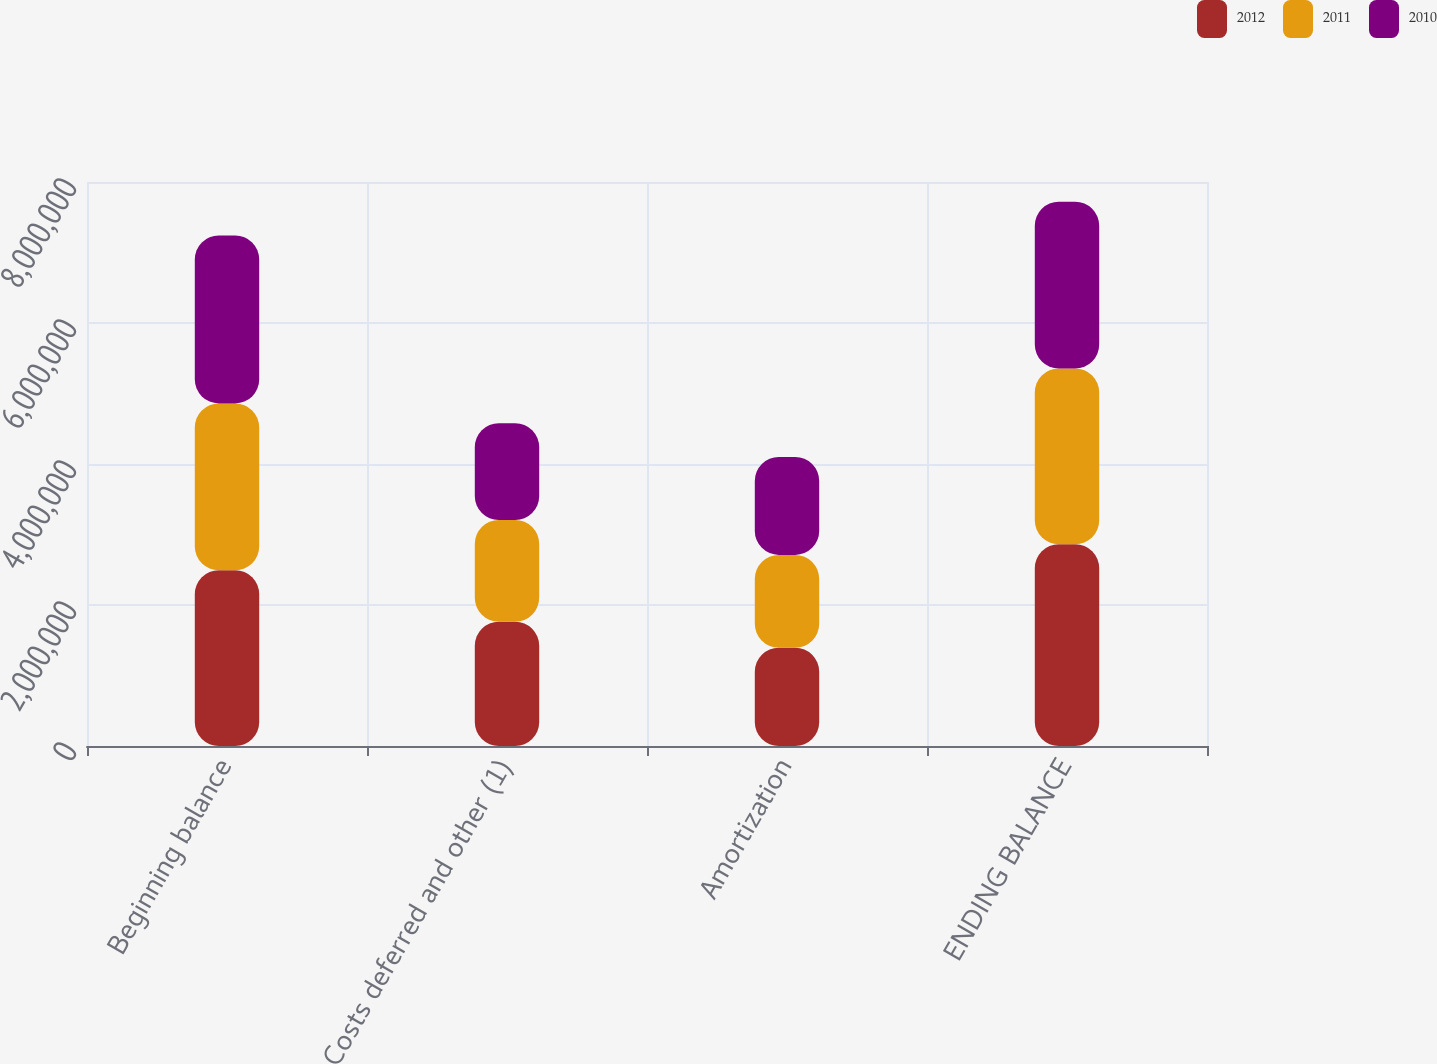Convert chart to OTSL. <chart><loc_0><loc_0><loc_500><loc_500><stacked_bar_chart><ecel><fcel>Beginning balance<fcel>Costs deferred and other (1)<fcel>Amortization<fcel>ENDING BALANCE<nl><fcel>2012<fcel>2.49286e+06<fcel>1.76256e+06<fcel>1.39425e+06<fcel>2.86116e+06<nl><fcel>2011<fcel>2.36618e+06<fcel>1.44331e+06<fcel>1.31664e+06<fcel>2.49286e+06<nl><fcel>2010<fcel>2.38282e+06<fcel>1.3724e+06<fcel>1.38904e+06<fcel>2.36618e+06<nl></chart> 